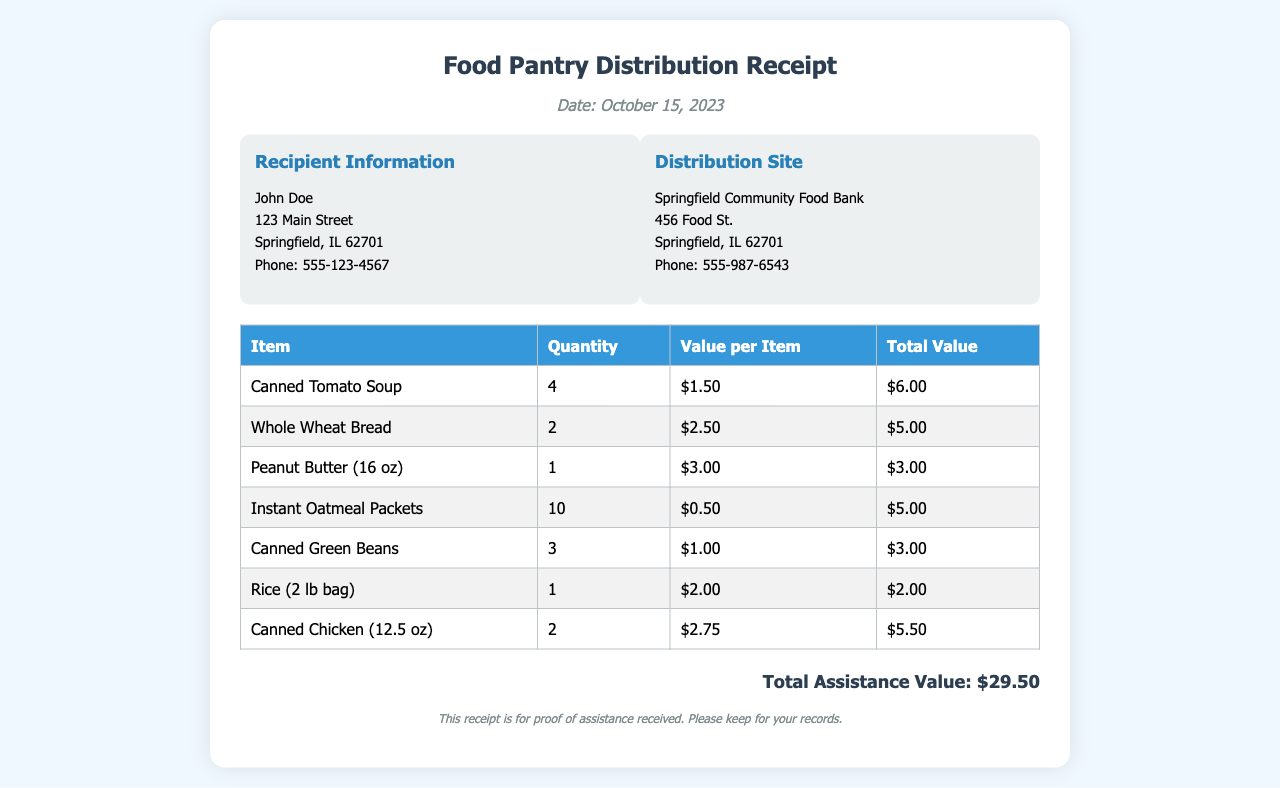What is the date of the receipt? The date of the receipt is clearly stated at the top of the document.
Answer: October 15, 2023 Who is the recipient of the assistance? The recipient's name is mentioned in the recipient information section.
Answer: John Doe What is the total assistance value? The total assistance value is summarized at the bottom of the document.
Answer: $29.50 How many cans of Tomato Soup were distributed? The quantity of each item, including Tomato Soup, is provided in the itemized list.
Answer: 4 What is the value per item for Peanut Butter? The value per item for Peanut Butter is specified in the table under "Value per Item."
Answer: $3.00 Which item had the highest quantity received? The item with the highest quantity is determined from the table listing all items and their respective quantities.
Answer: Instant Oatmeal Packets What is the address of the distribution site? The address of the distribution site can be found in the distribution site information section of the document.
Answer: 456 Food St., Springfield, IL 62701 How many bags of Rice were included? The quantity of Rice is indicated in the itemized list.
Answer: 1 Which organization provided the assistance? The organization providing the assistance is mentioned in the distribution site section.
Answer: Springfield Community Food Bank 